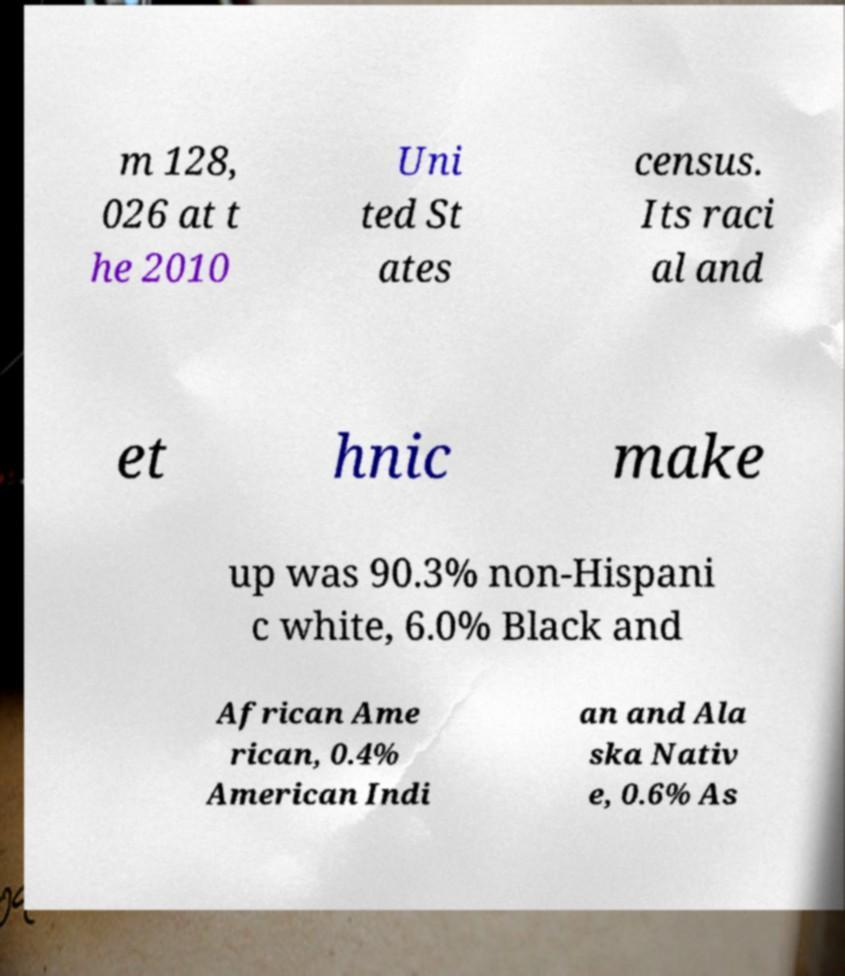Please read and relay the text visible in this image. What does it say? m 128, 026 at t he 2010 Uni ted St ates census. Its raci al and et hnic make up was 90.3% non-Hispani c white, 6.0% Black and African Ame rican, 0.4% American Indi an and Ala ska Nativ e, 0.6% As 